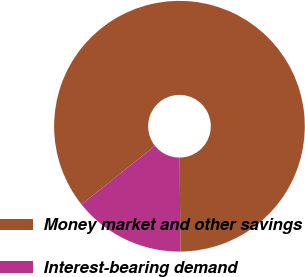Convert chart. <chart><loc_0><loc_0><loc_500><loc_500><pie_chart><fcel>Money market and other savings<fcel>Interest-bearing demand<nl><fcel>85.61%<fcel>14.39%<nl></chart> 